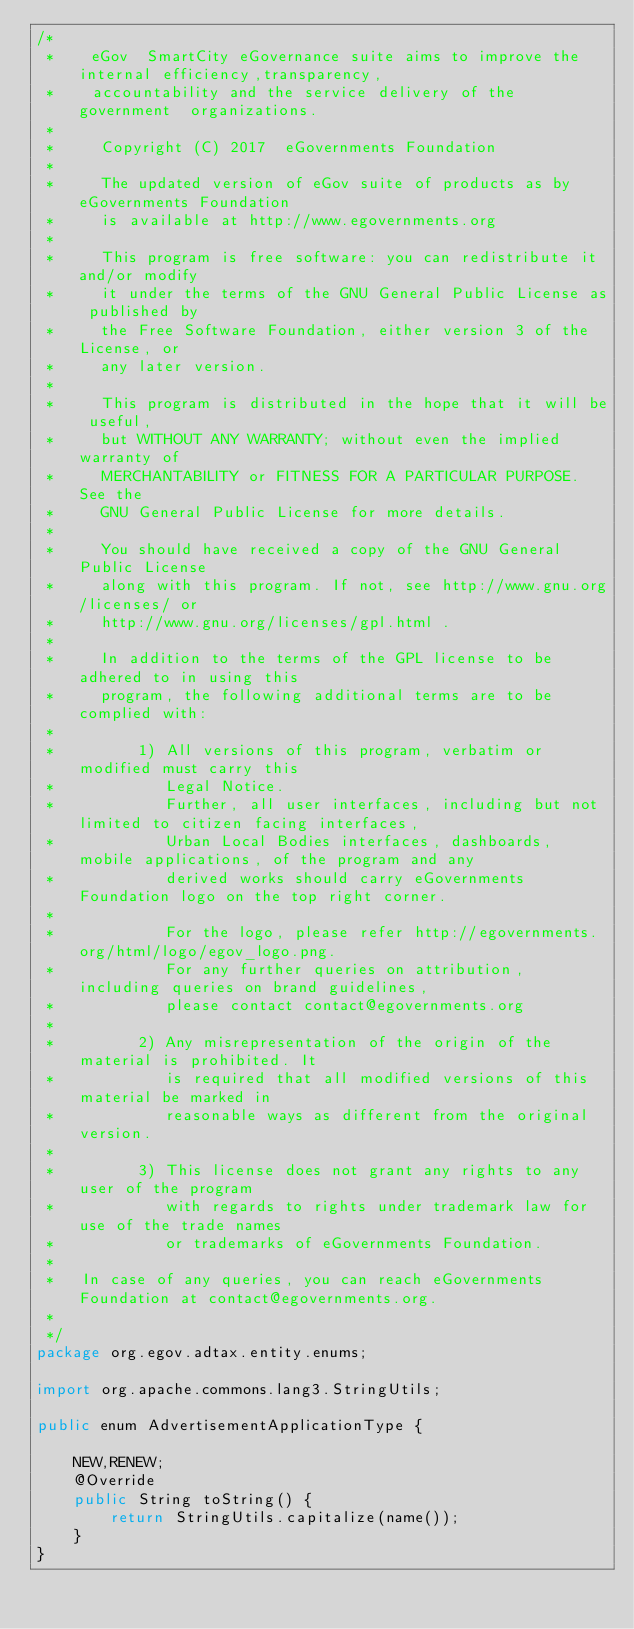Convert code to text. <code><loc_0><loc_0><loc_500><loc_500><_Java_>/*
 *    eGov  SmartCity eGovernance suite aims to improve the internal efficiency,transparency,
 *    accountability and the service delivery of the government  organizations.
 *
 *     Copyright (C) 2017  eGovernments Foundation
 *
 *     The updated version of eGov suite of products as by eGovernments Foundation
 *     is available at http://www.egovernments.org
 *
 *     This program is free software: you can redistribute it and/or modify
 *     it under the terms of the GNU General Public License as published by
 *     the Free Software Foundation, either version 3 of the License, or
 *     any later version.
 *
 *     This program is distributed in the hope that it will be useful,
 *     but WITHOUT ANY WARRANTY; without even the implied warranty of
 *     MERCHANTABILITY or FITNESS FOR A PARTICULAR PURPOSE.  See the
 *     GNU General Public License for more details.
 *
 *     You should have received a copy of the GNU General Public License
 *     along with this program. If not, see http://www.gnu.org/licenses/ or
 *     http://www.gnu.org/licenses/gpl.html .
 *
 *     In addition to the terms of the GPL license to be adhered to in using this
 *     program, the following additional terms are to be complied with:
 *
 *         1) All versions of this program, verbatim or modified must carry this
 *            Legal Notice.
 *            Further, all user interfaces, including but not limited to citizen facing interfaces,
 *            Urban Local Bodies interfaces, dashboards, mobile applications, of the program and any
 *            derived works should carry eGovernments Foundation logo on the top right corner.
 *
 *            For the logo, please refer http://egovernments.org/html/logo/egov_logo.png.
 *            For any further queries on attribution, including queries on brand guidelines,
 *            please contact contact@egovernments.org
 *
 *         2) Any misrepresentation of the origin of the material is prohibited. It
 *            is required that all modified versions of this material be marked in
 *            reasonable ways as different from the original version.
 *
 *         3) This license does not grant any rights to any user of the program
 *            with regards to rights under trademark law for use of the trade names
 *            or trademarks of eGovernments Foundation.
 *
 *   In case of any queries, you can reach eGovernments Foundation at contact@egovernments.org.
 *
 */
package org.egov.adtax.entity.enums;

import org.apache.commons.lang3.StringUtils;

public enum AdvertisementApplicationType {

    NEW,RENEW;
    @Override
    public String toString() {
        return StringUtils.capitalize(name());
    }
}
</code> 